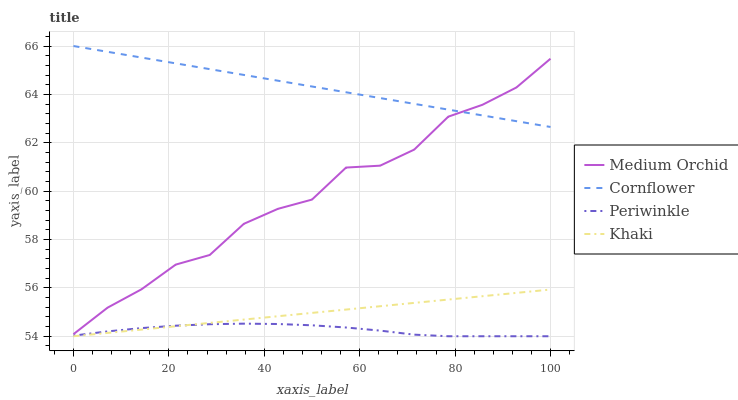Does Periwinkle have the minimum area under the curve?
Answer yes or no. Yes. Does Cornflower have the maximum area under the curve?
Answer yes or no. Yes. Does Medium Orchid have the minimum area under the curve?
Answer yes or no. No. Does Medium Orchid have the maximum area under the curve?
Answer yes or no. No. Is Cornflower the smoothest?
Answer yes or no. Yes. Is Medium Orchid the roughest?
Answer yes or no. Yes. Is Periwinkle the smoothest?
Answer yes or no. No. Is Periwinkle the roughest?
Answer yes or no. No. Does Periwinkle have the lowest value?
Answer yes or no. Yes. Does Medium Orchid have the lowest value?
Answer yes or no. No. Does Cornflower have the highest value?
Answer yes or no. Yes. Does Medium Orchid have the highest value?
Answer yes or no. No. Is Periwinkle less than Medium Orchid?
Answer yes or no. Yes. Is Medium Orchid greater than Khaki?
Answer yes or no. Yes. Does Medium Orchid intersect Cornflower?
Answer yes or no. Yes. Is Medium Orchid less than Cornflower?
Answer yes or no. No. Is Medium Orchid greater than Cornflower?
Answer yes or no. No. Does Periwinkle intersect Medium Orchid?
Answer yes or no. No. 